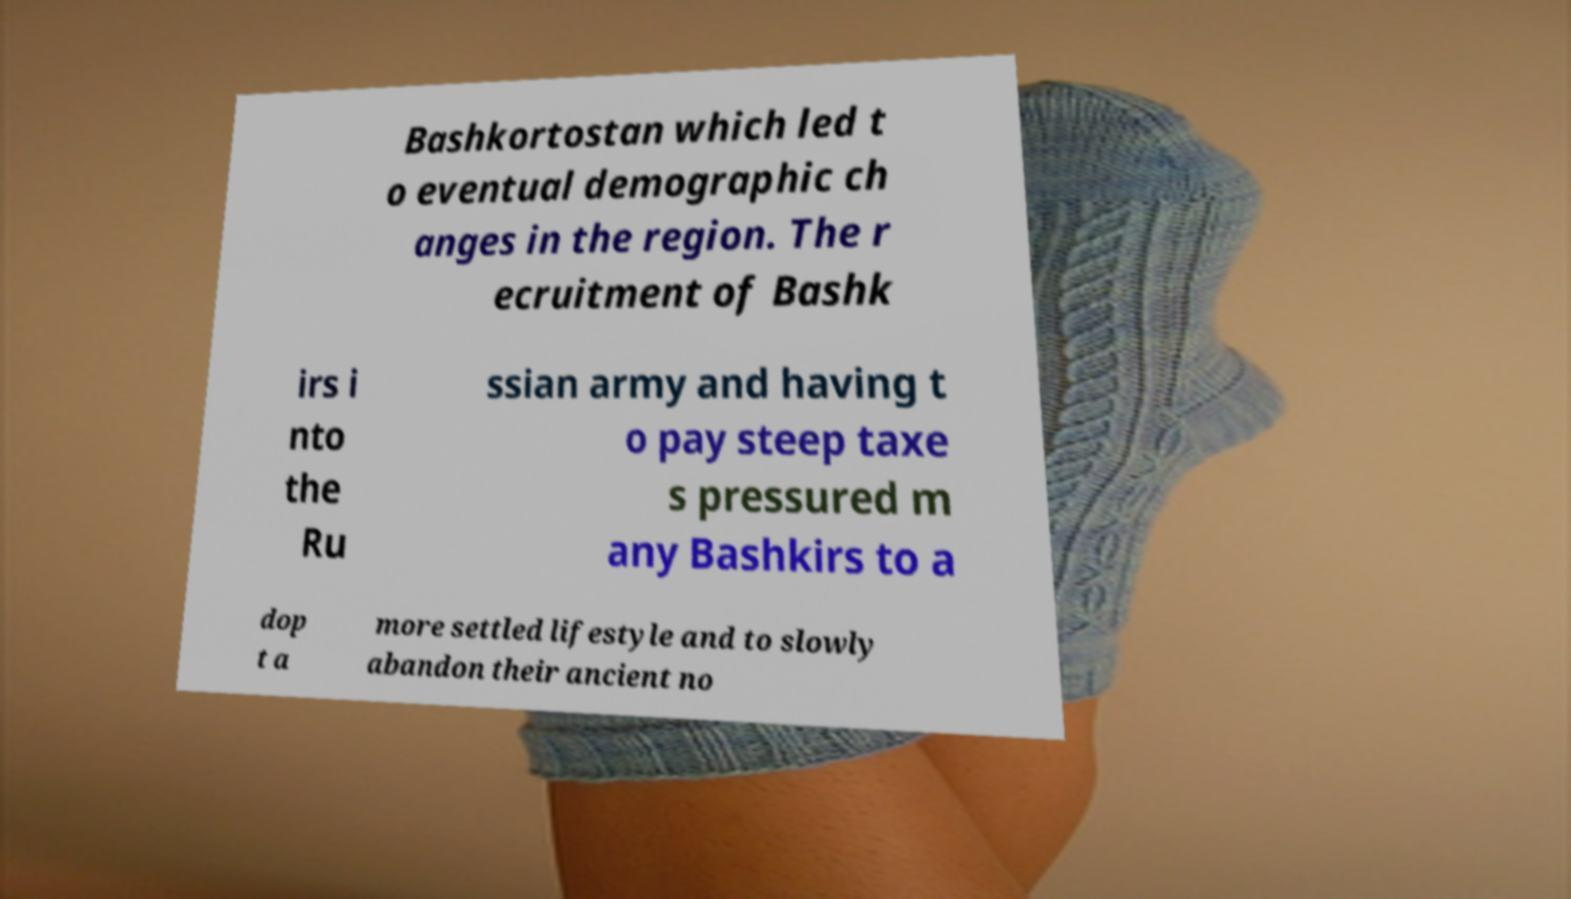Can you accurately transcribe the text from the provided image for me? Bashkortostan which led t o eventual demographic ch anges in the region. The r ecruitment of Bashk irs i nto the Ru ssian army and having t o pay steep taxe s pressured m any Bashkirs to a dop t a more settled lifestyle and to slowly abandon their ancient no 